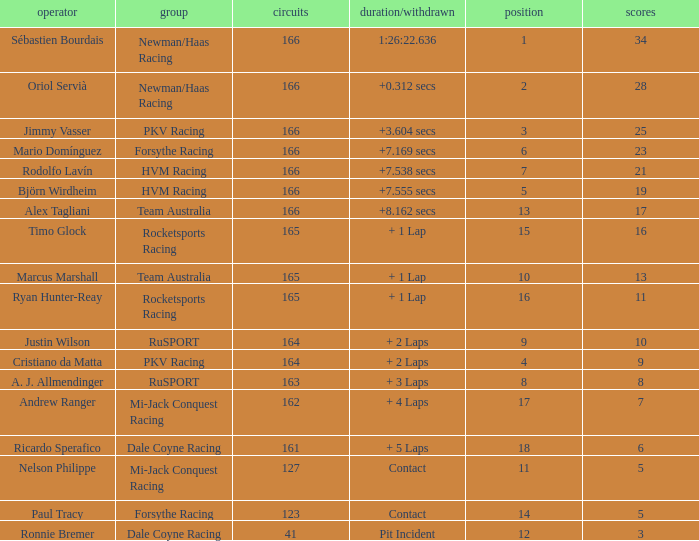What is the name of the driver with 6 points? Ricardo Sperafico. 